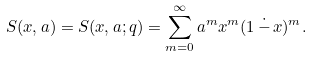<formula> <loc_0><loc_0><loc_500><loc_500>S ( x , a ) = S ( x , a ; q ) = \sum ^ { \infty } _ { m = 0 } a ^ { m } x ^ { m } ( 1 \, \dot { - } \, x ) ^ { m } .</formula> 